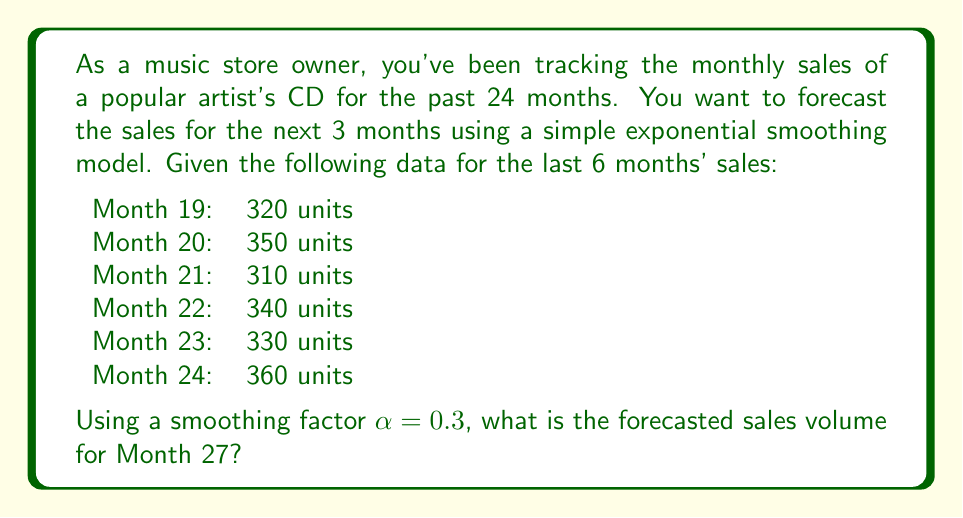Can you solve this math problem? To solve this problem, we'll use the simple exponential smoothing model, which is a time series forecasting technique. The formula for this model is:

$$F_{t+1} = \alpha Y_t + (1-\alpha)F_t$$

Where:
$F_{t+1}$ is the forecast for the next period
$\alpha$ is the smoothing factor (given as 0.3)
$Y_t$ is the actual value at time t
$F_t$ is the forecast for the current period

Let's calculate step by step:

1. Start with the last known actual value (Month 24): 360 units

2. Calculate the forecast for Month 25:
   $F_{25} = 0.3 \times 360 + (1-0.3) \times 360 = 360$

3. For Month 26, we don't have an actual value, so we use the previous forecast:
   $F_{26} = 0.3 \times 360 + (1-0.3) \times 360 = 360$

4. For Month 27, we again use the previous forecast:
   $F_{27} = 0.3 \times 360 + (1-0.3) \times 360 = 360$

Note that in this case, because we don't have actual values for months 25 and 26, and our initial forecast equals the last actual value, the forecast remains constant. This is a limitation of using simple exponential smoothing for multiple periods ahead without new data.
Answer: The forecasted sales volume for Month 27 is 360 units. 